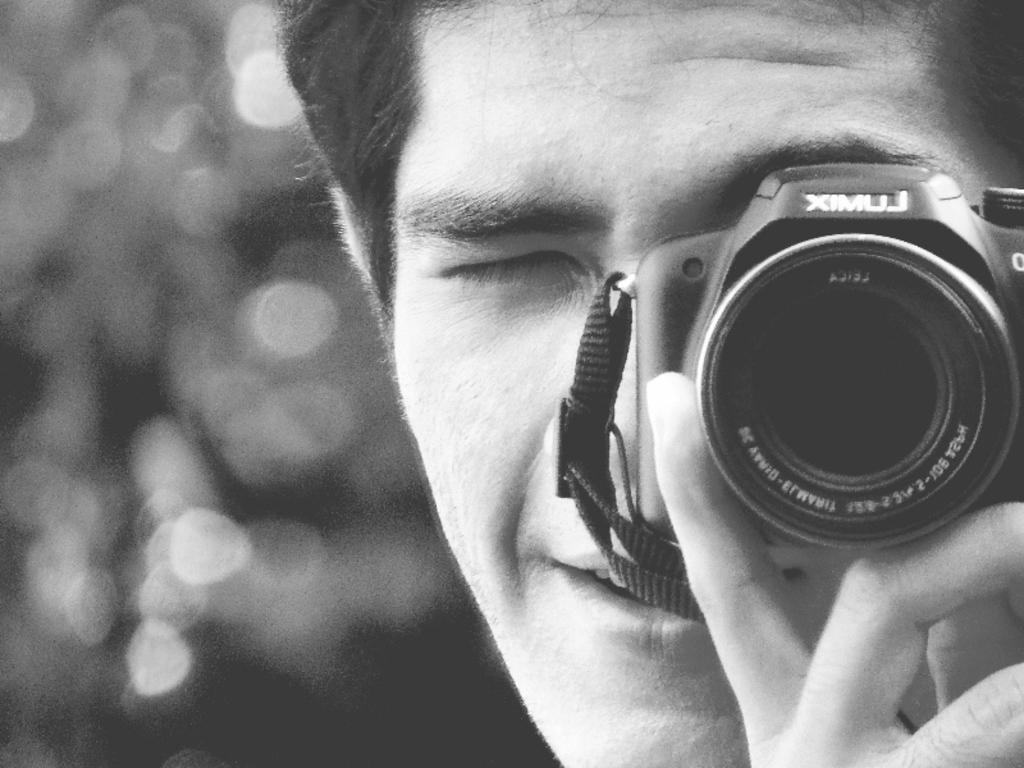What is the main subject of the image? There is a person in the image. What is the person holding in their hand? The person is holding a camera in their hand. What is the color scheme of the image? The image is in black and white. What type of tail can be seen on the person's uncle in the image? There is no uncle or tail present in the image; it only features a person holding a camera. 